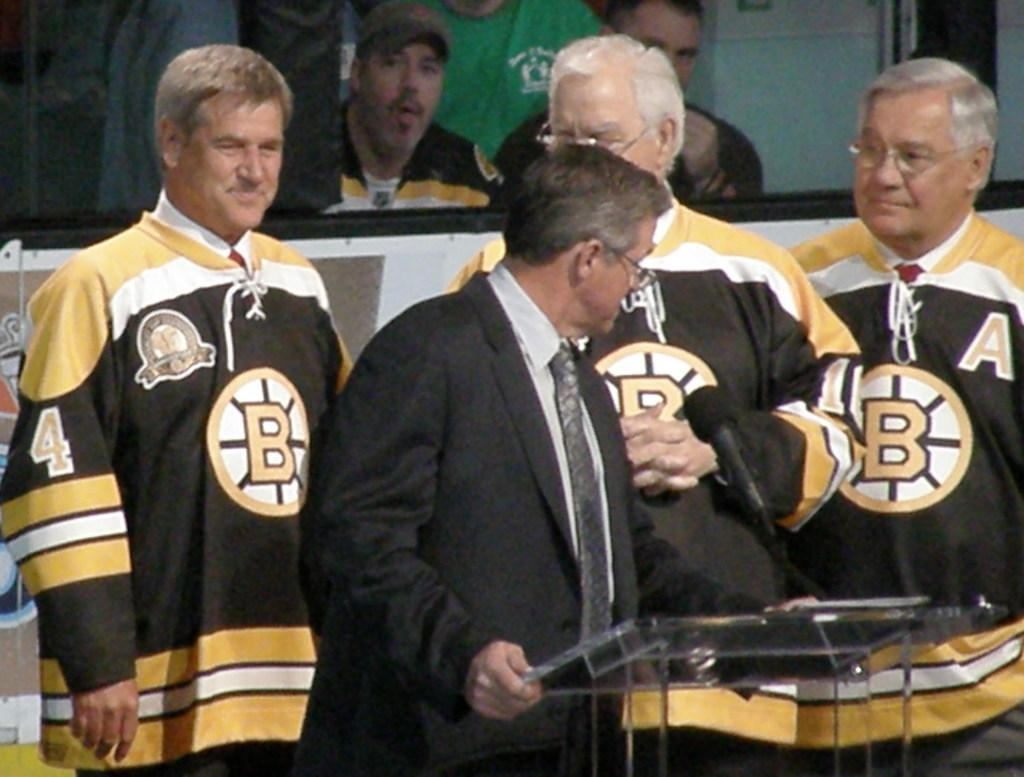Provide a one-sentence caption for the provided image. men wearing bruin jerseys, one of them specifically with the number 4. 